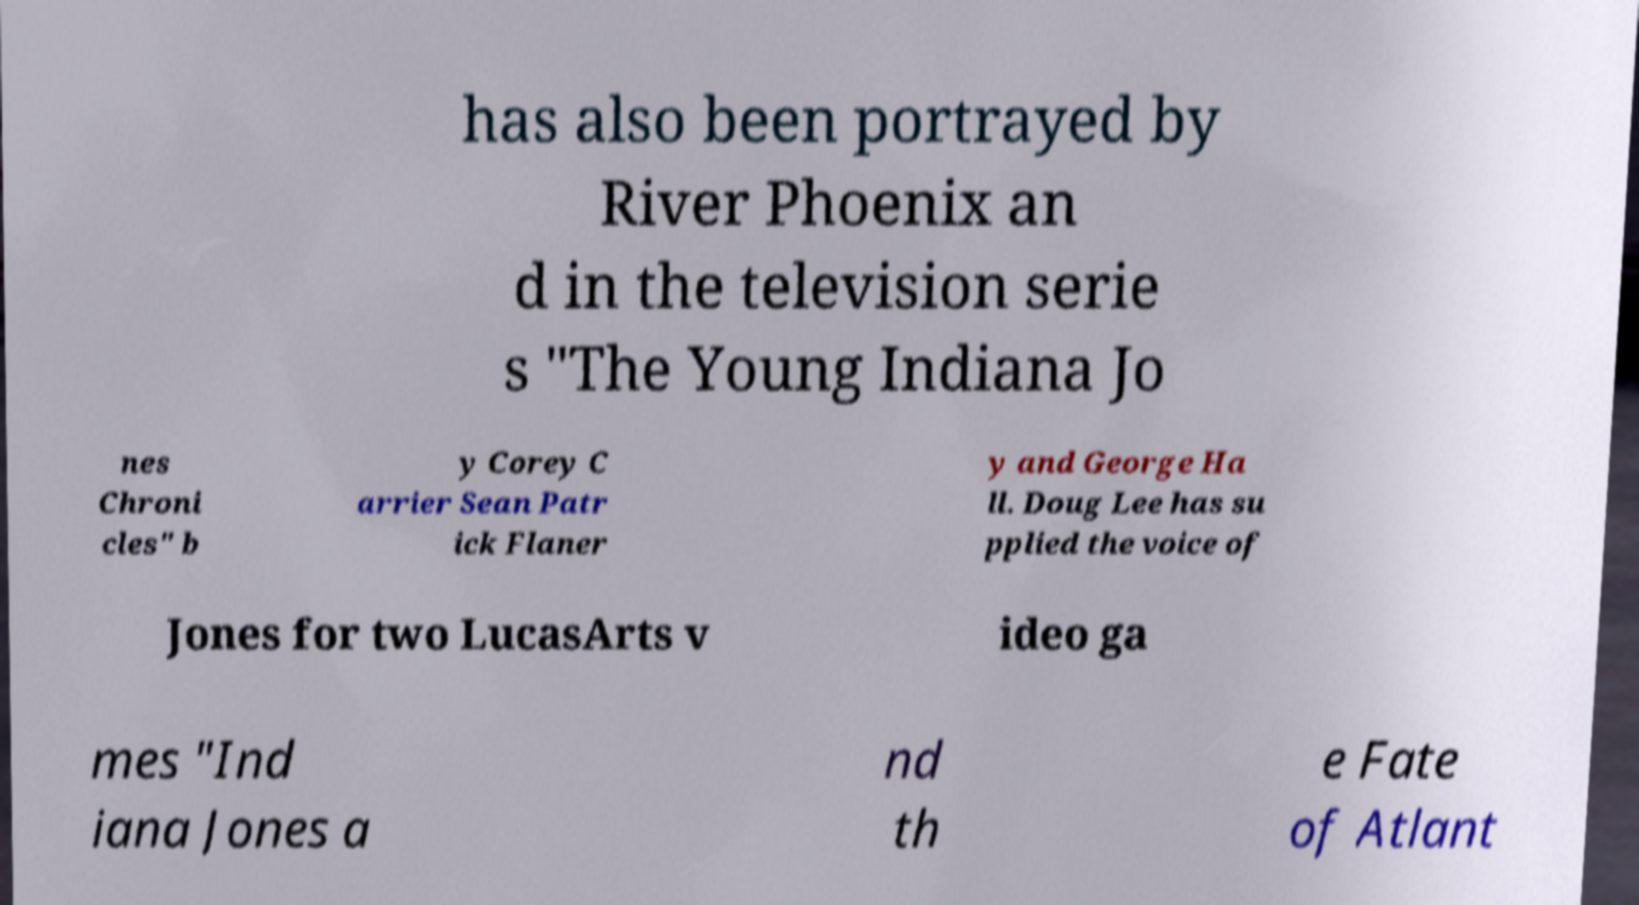I need the written content from this picture converted into text. Can you do that? has also been portrayed by River Phoenix an d in the television serie s "The Young Indiana Jo nes Chroni cles" b y Corey C arrier Sean Patr ick Flaner y and George Ha ll. Doug Lee has su pplied the voice of Jones for two LucasArts v ideo ga mes "Ind iana Jones a nd th e Fate of Atlant 